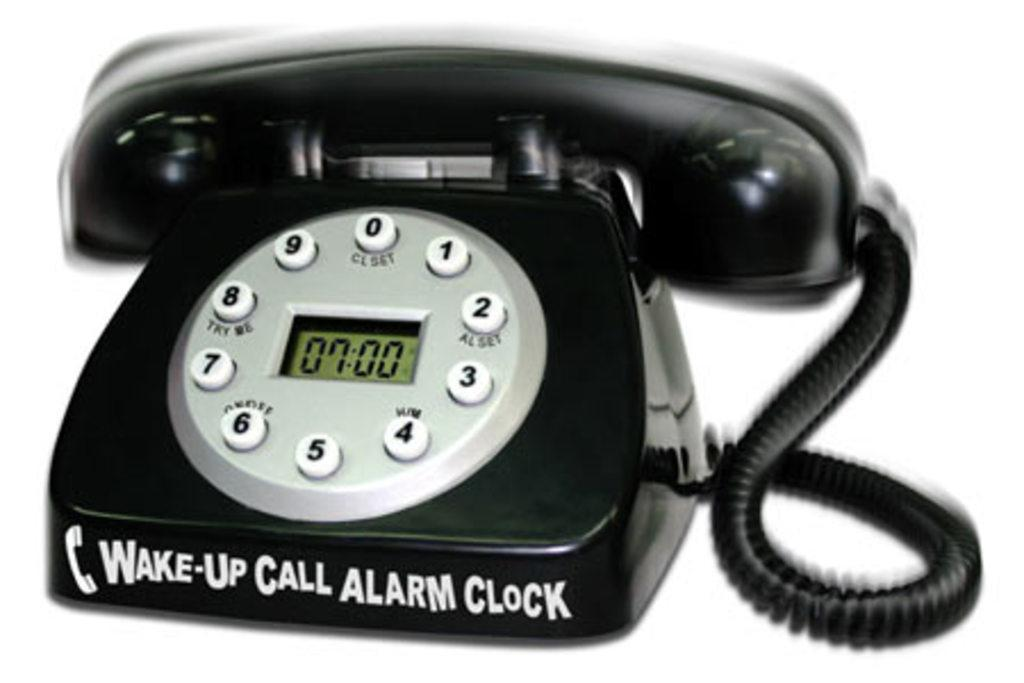<image>
Write a terse but informative summary of the picture. A wake-up call alarm clock is fashioned as a phone. 